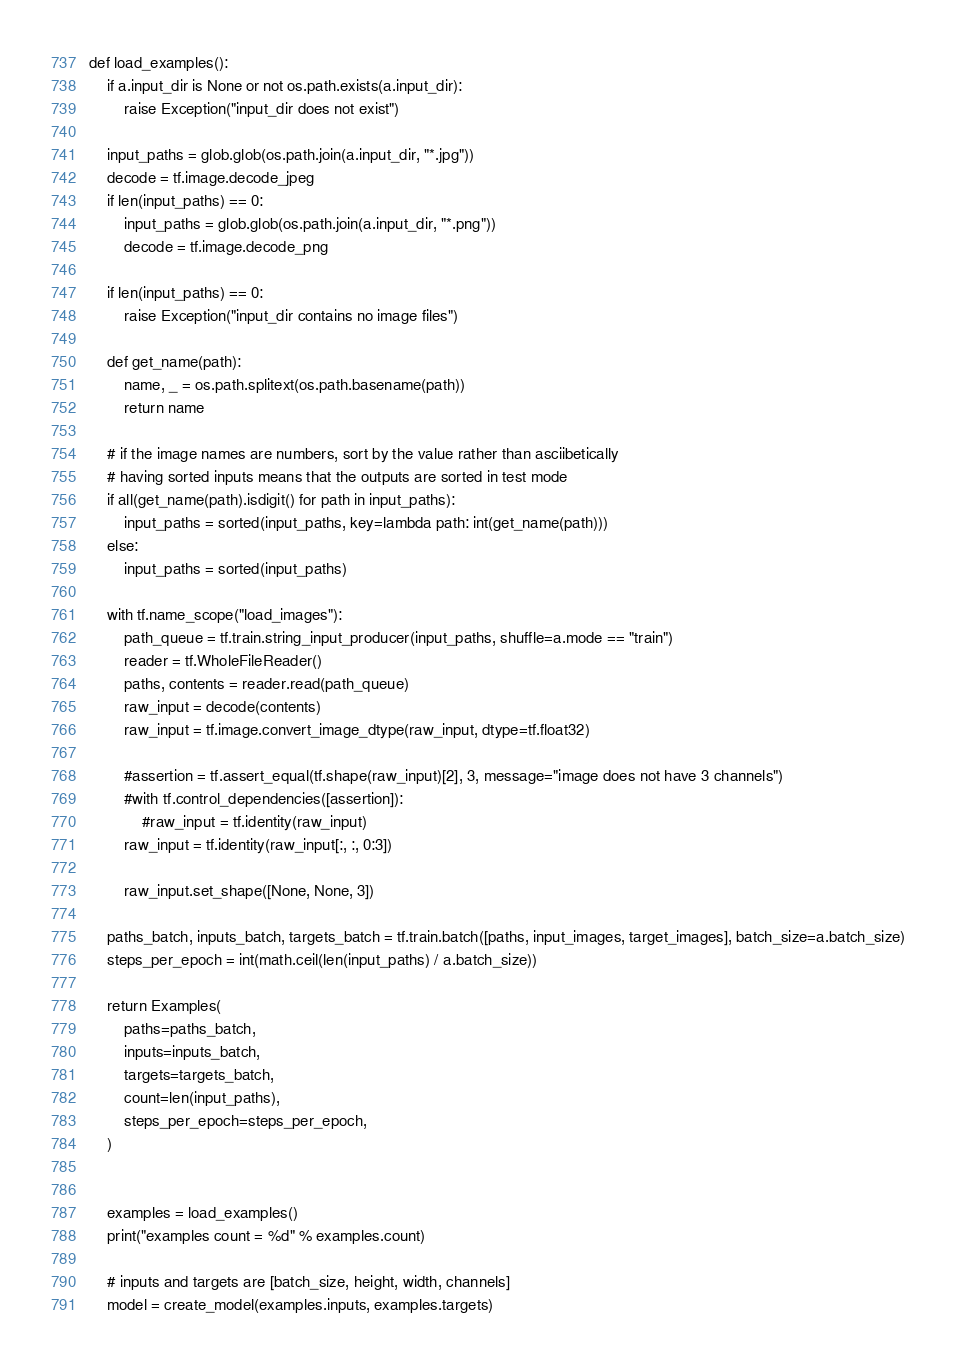Convert code to text. <code><loc_0><loc_0><loc_500><loc_500><_Python_>
def load_examples():
    if a.input_dir is None or not os.path.exists(a.input_dir):
        raise Exception("input_dir does not exist")

    input_paths = glob.glob(os.path.join(a.input_dir, "*.jpg"))
    decode = tf.image.decode_jpeg
    if len(input_paths) == 0:
        input_paths = glob.glob(os.path.join(a.input_dir, "*.png"))
        decode = tf.image.decode_png

    if len(input_paths) == 0:
        raise Exception("input_dir contains no image files")

    def get_name(path):
        name, _ = os.path.splitext(os.path.basename(path))
        return name

    # if the image names are numbers, sort by the value rather than asciibetically
    # having sorted inputs means that the outputs are sorted in test mode
    if all(get_name(path).isdigit() for path in input_paths):
        input_paths = sorted(input_paths, key=lambda path: int(get_name(path)))
    else:
        input_paths = sorted(input_paths)

    with tf.name_scope("load_images"):
        path_queue = tf.train.string_input_producer(input_paths, shuffle=a.mode == "train")
        reader = tf.WholeFileReader()
        paths, contents = reader.read(path_queue)
        raw_input = decode(contents)
        raw_input = tf.image.convert_image_dtype(raw_input, dtype=tf.float32)

        #assertion = tf.assert_equal(tf.shape(raw_input)[2], 3, message="image does not have 3 channels")
        #with tf.control_dependencies([assertion]):
            #raw_input = tf.identity(raw_input)
        raw_input = tf.identity(raw_input[:, :, 0:3])
        
        raw_input.set_shape([None, None, 3])

    paths_batch, inputs_batch, targets_batch = tf.train.batch([paths, input_images, target_images], batch_size=a.batch_size)
    steps_per_epoch = int(math.ceil(len(input_paths) / a.batch_size))

    return Examples(
        paths=paths_batch,
        inputs=inputs_batch,
        targets=targets_batch,
        count=len(input_paths),
        steps_per_epoch=steps_per_epoch,
    )


    examples = load_examples()
    print("examples count = %d" % examples.count)

    # inputs and targets are [batch_size, height, width, channels]
    model = create_model(examples.inputs, examples.targets)</code> 